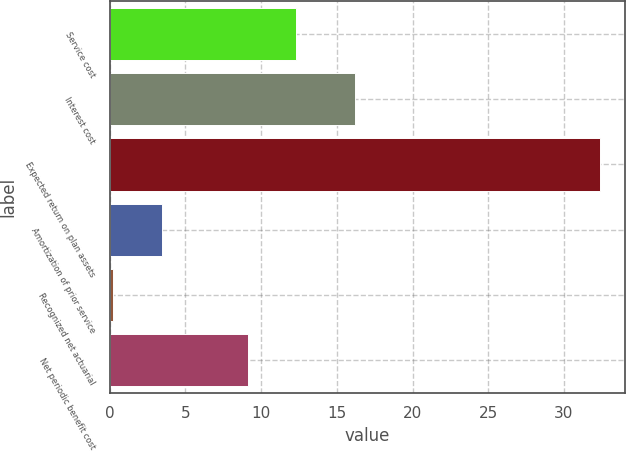Convert chart to OTSL. <chart><loc_0><loc_0><loc_500><loc_500><bar_chart><fcel>Service cost<fcel>Interest cost<fcel>Expected return on plan assets<fcel>Amortization of prior service<fcel>Recognized net actuarial<fcel>Net periodic benefit cost<nl><fcel>12.32<fcel>16.2<fcel>32.4<fcel>3.42<fcel>0.2<fcel>9.1<nl></chart> 